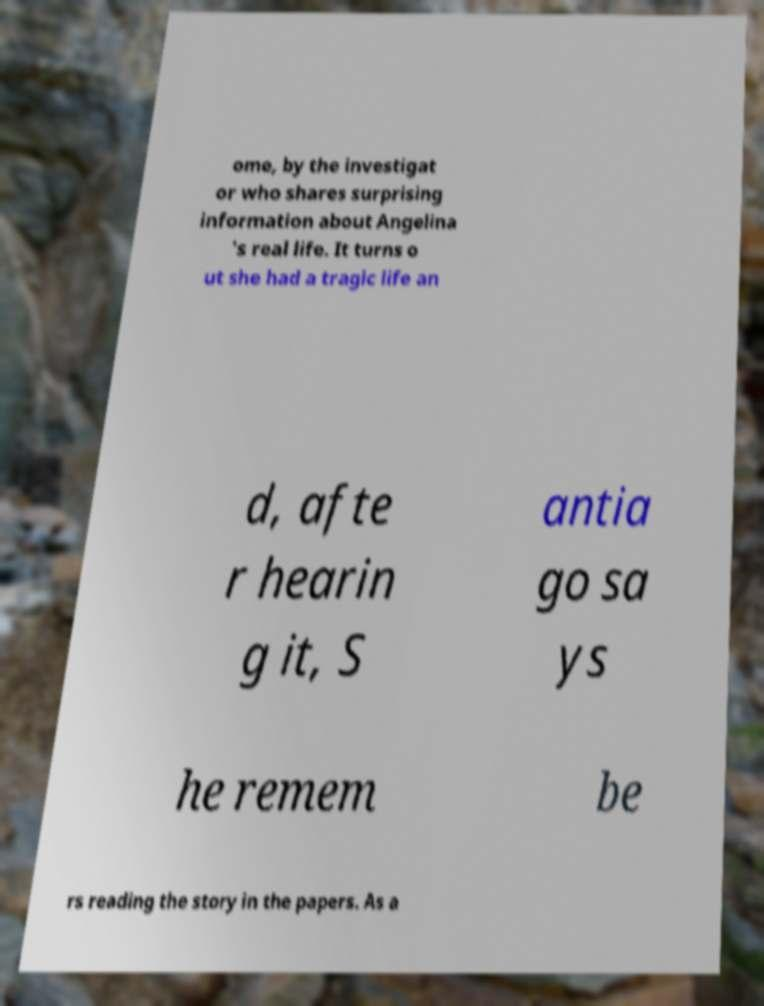Please identify and transcribe the text found in this image. ome, by the investigat or who shares surprising information about Angelina 's real life. It turns o ut she had a tragic life an d, afte r hearin g it, S antia go sa ys he remem be rs reading the story in the papers. As a 